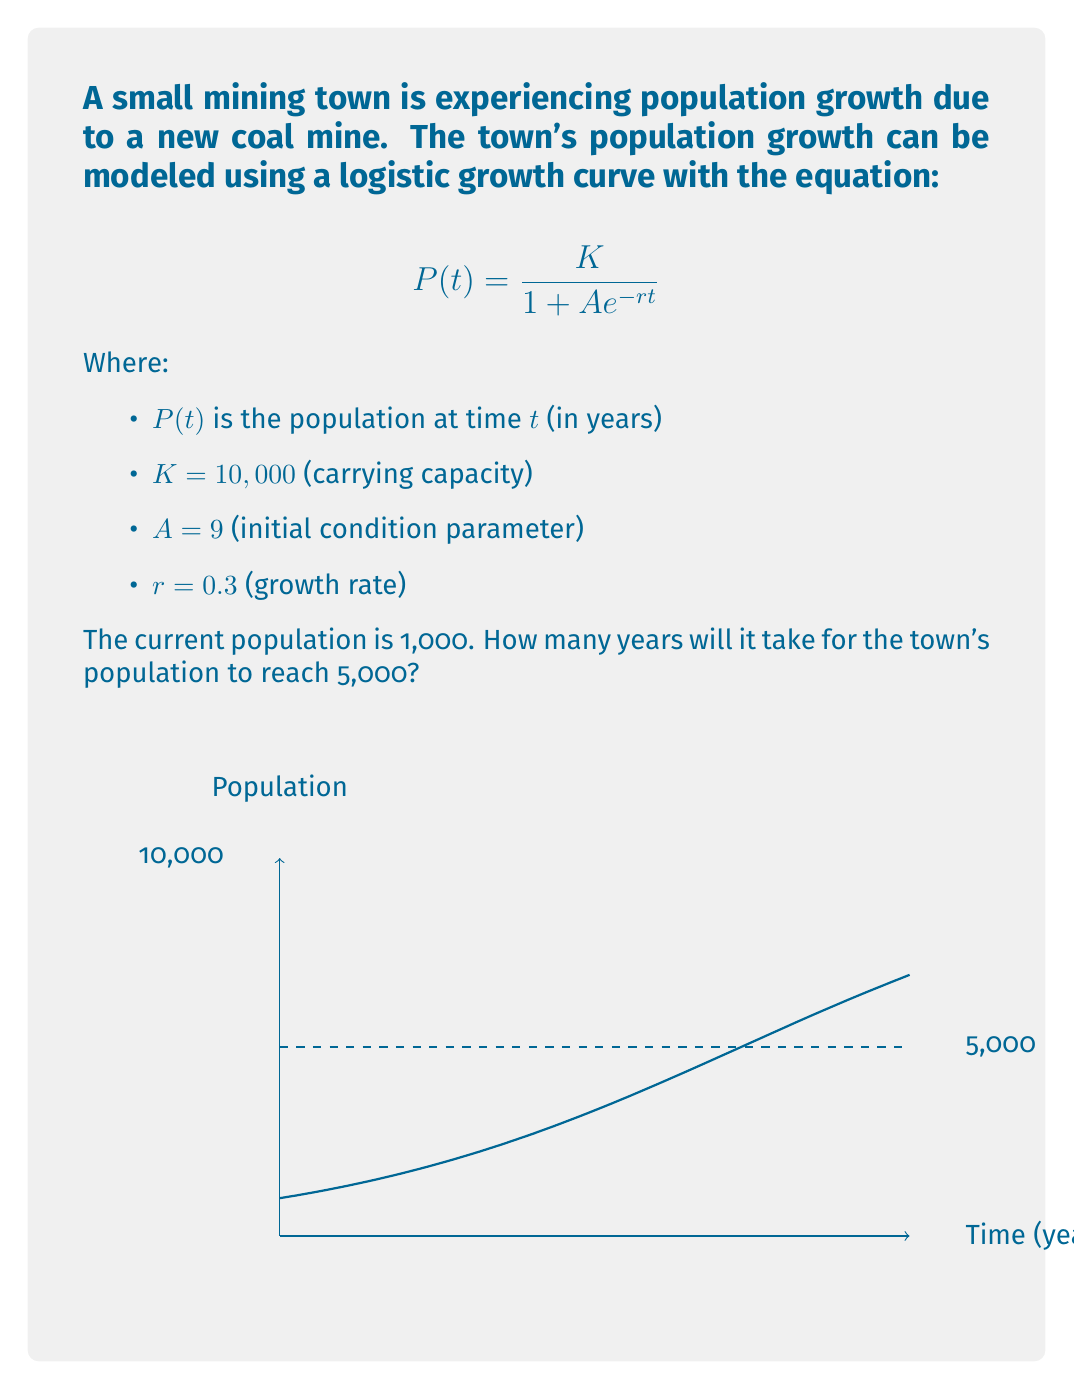Show me your answer to this math problem. To solve this problem, we need to use the logistic growth equation and solve for $t$ when $P(t) = 5,000$. Let's break it down step-by-step:

1) We start with the logistic growth equation:
   $$P(t) = \frac{K}{1 + Ae^{-rt}}$$

2) We know that $K = 10,000$, $A = 9$, and $r = 0.3$. We want to find $t$ when $P(t) = 5,000$. Let's substitute these values:
   $$5,000 = \frac{10,000}{1 + 9e^{-0.3t}}$$

3) Now, let's solve this equation for $t$:
   $$\frac{10,000}{5,000} = 1 + 9e^{-0.3t}$$
   $$2 = 1 + 9e^{-0.3t}$$
   $$1 = 9e^{-0.3t}$$

4) Take the natural log of both sides:
   $$\ln(1) = \ln(9e^{-0.3t})$$
   $$0 = \ln(9) - 0.3t$$

5) Solve for $t$:
   $$0.3t = \ln(9)$$
   $$t = \frac{\ln(9)}{0.3}$$

6) Calculate the final value:
   $$t \approx 7.36$$

Therefore, it will take approximately 7.36 years for the town's population to reach 5,000.
Answer: 7.36 years 